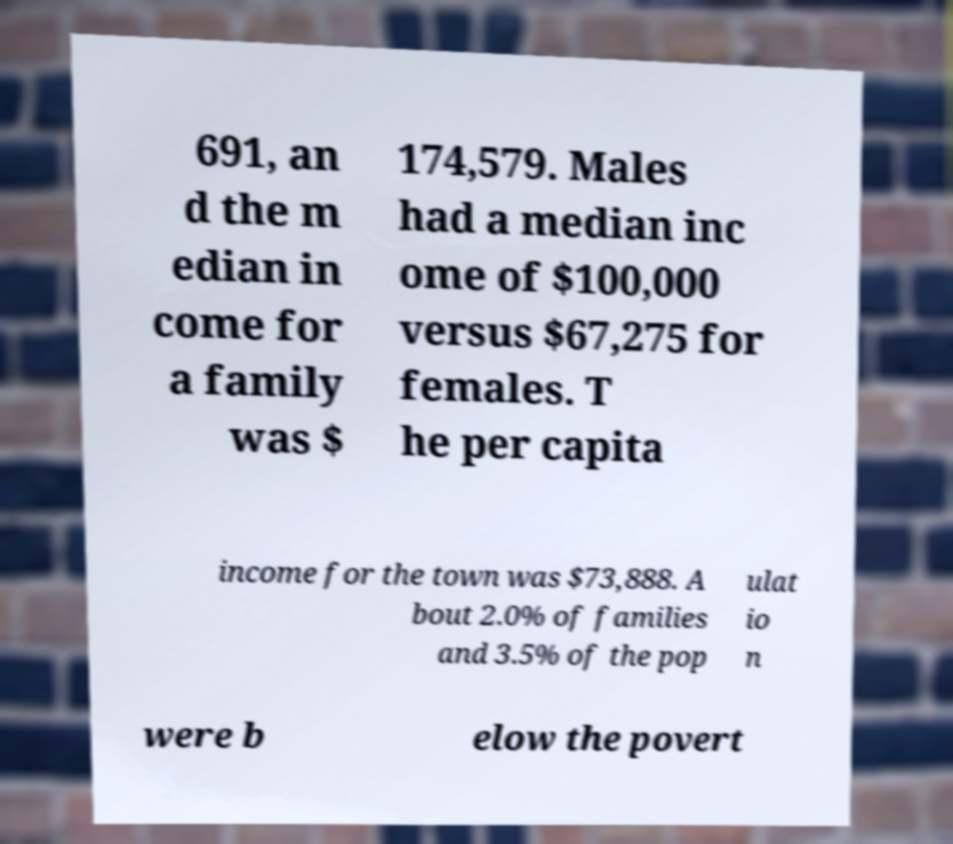Can you read and provide the text displayed in the image?This photo seems to have some interesting text. Can you extract and type it out for me? 691, an d the m edian in come for a family was $ 174,579. Males had a median inc ome of $100,000 versus $67,275 for females. T he per capita income for the town was $73,888. A bout 2.0% of families and 3.5% of the pop ulat io n were b elow the povert 